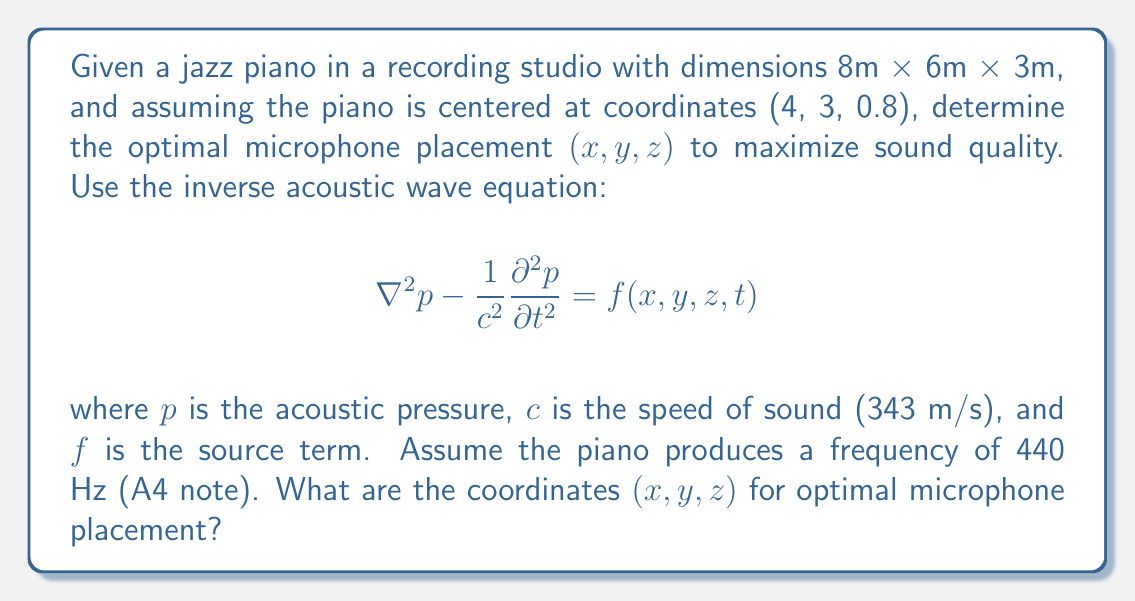Solve this math problem. To solve this inverse problem and determine the optimal microphone placement, we'll follow these steps:

1) First, we need to consider the wavelength of the sound. For a 440 Hz tone:
   $$ \lambda = \frac{c}{f} = \frac{343 \text{ m/s}}{440 \text{ Hz}} \approx 0.78 \text{ m} $$

2) In acoustic recording, a common rule of thumb is the "3:1 rule", which suggests placing the microphone at a distance of about 3 times the distance between the sound source and the nearest reflective surface.

3) The nearest reflective surface to the piano is likely the floor, at a distance of 0.8 m. So, the optimal distance from the piano should be:
   $$ 3 \times 0.8 \text{ m} = 2.4 \text{ m} $$

4) To avoid standing waves and room modes, it's often best to place the microphone asymmetrically. We can use the golden ratio (approximately 1.618) to determine optimal ratios for placement.

5) For the x-coordinate:
   $$ x = 4 + \frac{2.4}{1.618} \approx 5.48 \text{ m} $$

6) For the y-coordinate:
   $$ y = 3 + \frac{2.4}{(1.618)^2} \approx 3.92 \text{ m} $$

7) For the z-coordinate, we want to be above the piano but not too close to the ceiling:
   $$ z = 0.8 + \frac{2.4}{(1.618)^3} \approx 1.57 \text{ m} $$

8) These coordinates (5.48, 3.92, 1.57) provide a good starting point for microphone placement, considering both the acoustic properties of the room and the characteristics of the sound source.

9) In practice, fine-tuning would be necessary, possibly using techniques like impulse response measurements or acoustic modeling software to further optimize the placement.
Answer: (5.48, 3.92, 1.57) 